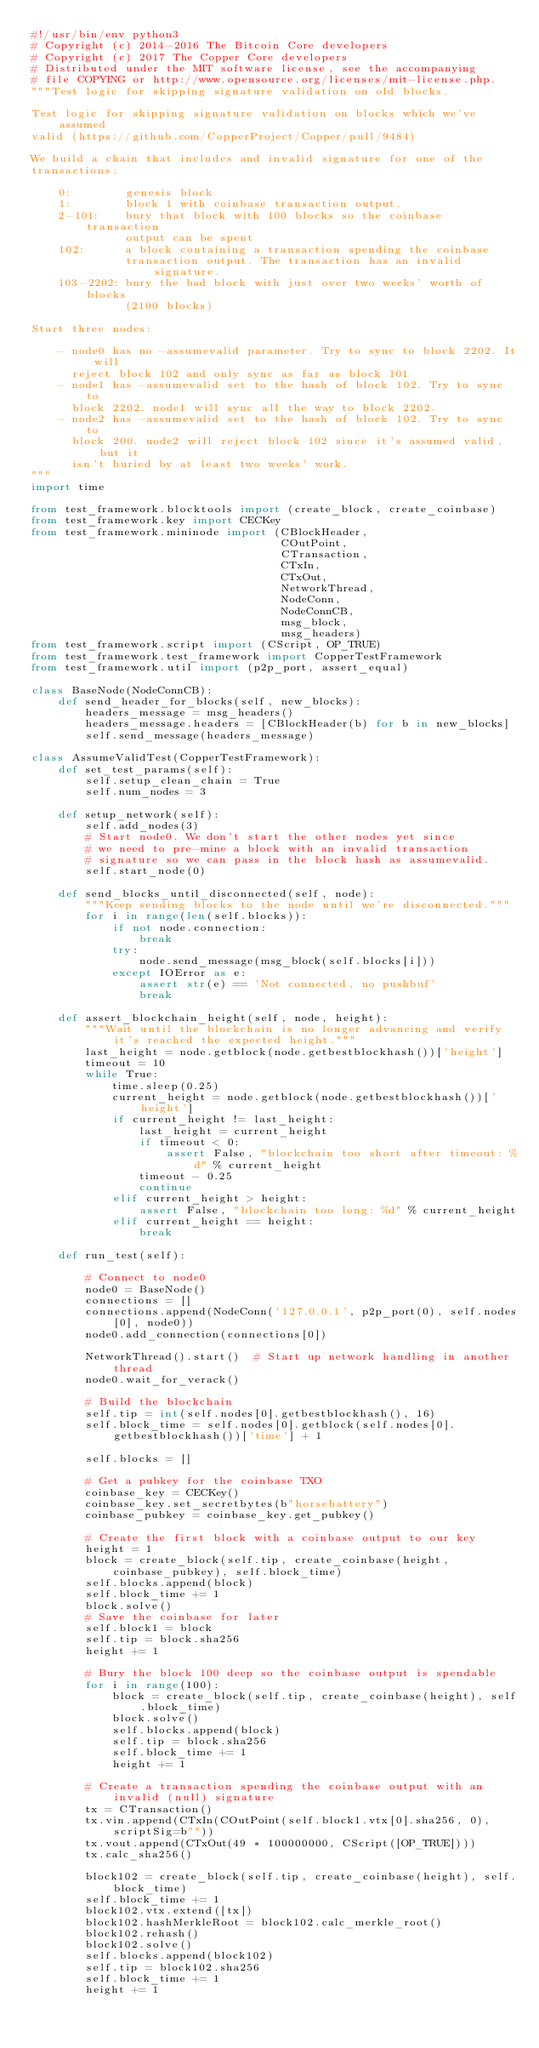Convert code to text. <code><loc_0><loc_0><loc_500><loc_500><_Python_>#!/usr/bin/env python3
# Copyright (c) 2014-2016 The Bitcoin Core developers
# Copyright (c) 2017 The Copper Core developers
# Distributed under the MIT software license, see the accompanying
# file COPYING or http://www.opensource.org/licenses/mit-license.php.
"""Test logic for skipping signature validation on old blocks.

Test logic for skipping signature validation on blocks which we've assumed
valid (https://github.com/CopperProject/Copper/pull/9484)

We build a chain that includes and invalid signature for one of the
transactions:

    0:        genesis block
    1:        block 1 with coinbase transaction output.
    2-101:    bury that block with 100 blocks so the coinbase transaction
              output can be spent
    102:      a block containing a transaction spending the coinbase
              transaction output. The transaction has an invalid signature.
    103-2202: bury the bad block with just over two weeks' worth of blocks
              (2100 blocks)

Start three nodes:

    - node0 has no -assumevalid parameter. Try to sync to block 2202. It will
      reject block 102 and only sync as far as block 101
    - node1 has -assumevalid set to the hash of block 102. Try to sync to
      block 2202. node1 will sync all the way to block 2202.
    - node2 has -assumevalid set to the hash of block 102. Try to sync to
      block 200. node2 will reject block 102 since it's assumed valid, but it
      isn't buried by at least two weeks' work.
"""
import time

from test_framework.blocktools import (create_block, create_coinbase)
from test_framework.key import CECKey
from test_framework.mininode import (CBlockHeader,
                                     COutPoint,
                                     CTransaction,
                                     CTxIn,
                                     CTxOut,
                                     NetworkThread,
                                     NodeConn,
                                     NodeConnCB,
                                     msg_block,
                                     msg_headers)
from test_framework.script import (CScript, OP_TRUE)
from test_framework.test_framework import CopperTestFramework
from test_framework.util import (p2p_port, assert_equal)

class BaseNode(NodeConnCB):
    def send_header_for_blocks(self, new_blocks):
        headers_message = msg_headers()
        headers_message.headers = [CBlockHeader(b) for b in new_blocks]
        self.send_message(headers_message)

class AssumeValidTest(CopperTestFramework):
    def set_test_params(self):
        self.setup_clean_chain = True
        self.num_nodes = 3

    def setup_network(self):
        self.add_nodes(3)
        # Start node0. We don't start the other nodes yet since
        # we need to pre-mine a block with an invalid transaction
        # signature so we can pass in the block hash as assumevalid.
        self.start_node(0)

    def send_blocks_until_disconnected(self, node):
        """Keep sending blocks to the node until we're disconnected."""
        for i in range(len(self.blocks)):
            if not node.connection:
                break
            try:
                node.send_message(msg_block(self.blocks[i]))
            except IOError as e:
                assert str(e) == 'Not connected, no pushbuf'
                break

    def assert_blockchain_height(self, node, height):
        """Wait until the blockchain is no longer advancing and verify it's reached the expected height."""
        last_height = node.getblock(node.getbestblockhash())['height']
        timeout = 10
        while True:
            time.sleep(0.25)
            current_height = node.getblock(node.getbestblockhash())['height']
            if current_height != last_height:
                last_height = current_height
                if timeout < 0:
                    assert False, "blockchain too short after timeout: %d" % current_height
                timeout - 0.25
                continue
            elif current_height > height:
                assert False, "blockchain too long: %d" % current_height
            elif current_height == height:
                break

    def run_test(self):

        # Connect to node0
        node0 = BaseNode()
        connections = []
        connections.append(NodeConn('127.0.0.1', p2p_port(0), self.nodes[0], node0))
        node0.add_connection(connections[0])

        NetworkThread().start()  # Start up network handling in another thread
        node0.wait_for_verack()

        # Build the blockchain
        self.tip = int(self.nodes[0].getbestblockhash(), 16)
        self.block_time = self.nodes[0].getblock(self.nodes[0].getbestblockhash())['time'] + 1

        self.blocks = []

        # Get a pubkey for the coinbase TXO
        coinbase_key = CECKey()
        coinbase_key.set_secretbytes(b"horsebattery")
        coinbase_pubkey = coinbase_key.get_pubkey()

        # Create the first block with a coinbase output to our key
        height = 1
        block = create_block(self.tip, create_coinbase(height, coinbase_pubkey), self.block_time)
        self.blocks.append(block)
        self.block_time += 1
        block.solve()
        # Save the coinbase for later
        self.block1 = block
        self.tip = block.sha256
        height += 1

        # Bury the block 100 deep so the coinbase output is spendable
        for i in range(100):
            block = create_block(self.tip, create_coinbase(height), self.block_time)
            block.solve()
            self.blocks.append(block)
            self.tip = block.sha256
            self.block_time += 1
            height += 1

        # Create a transaction spending the coinbase output with an invalid (null) signature
        tx = CTransaction()
        tx.vin.append(CTxIn(COutPoint(self.block1.vtx[0].sha256, 0), scriptSig=b""))
        tx.vout.append(CTxOut(49 * 100000000, CScript([OP_TRUE])))
        tx.calc_sha256()

        block102 = create_block(self.tip, create_coinbase(height), self.block_time)
        self.block_time += 1
        block102.vtx.extend([tx])
        block102.hashMerkleRoot = block102.calc_merkle_root()
        block102.rehash()
        block102.solve()
        self.blocks.append(block102)
        self.tip = block102.sha256
        self.block_time += 1
        height += 1
</code> 